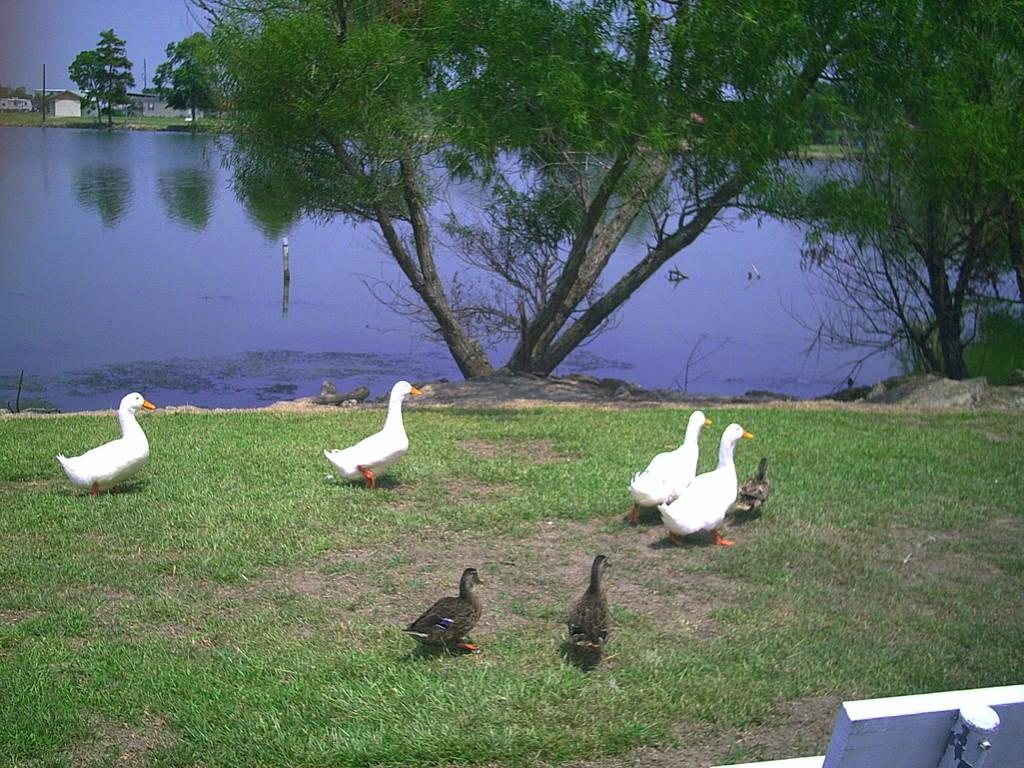What animals can be seen on the ground in the image? There are ducks on the ground in the image. What type of vegetation is present in the image? There are trees in the image. What structures can be seen in the image? There are poles and houses in the image. What natural element is visible in the image? There is water visible in the image. What is visible in the background of the image? The sky is visible in the background of the image. What type of yard can be seen in the image? There is no yard present in the image. How does the anger of the ducks affect the water in the image? There is no indication of anger in the image, and the ducks do not affect the water in any way. 